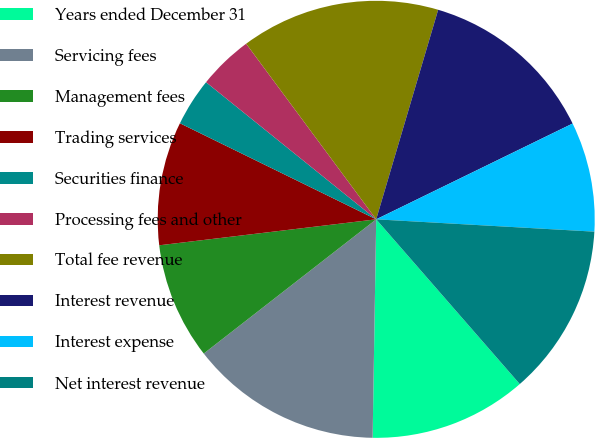Convert chart. <chart><loc_0><loc_0><loc_500><loc_500><pie_chart><fcel>Years ended December 31<fcel>Servicing fees<fcel>Management fees<fcel>Trading services<fcel>Securities finance<fcel>Processing fees and other<fcel>Total fee revenue<fcel>Interest revenue<fcel>Interest expense<fcel>Net interest revenue<nl><fcel>11.67%<fcel>14.21%<fcel>8.63%<fcel>9.14%<fcel>3.55%<fcel>4.06%<fcel>14.72%<fcel>13.2%<fcel>8.12%<fcel>12.69%<nl></chart> 